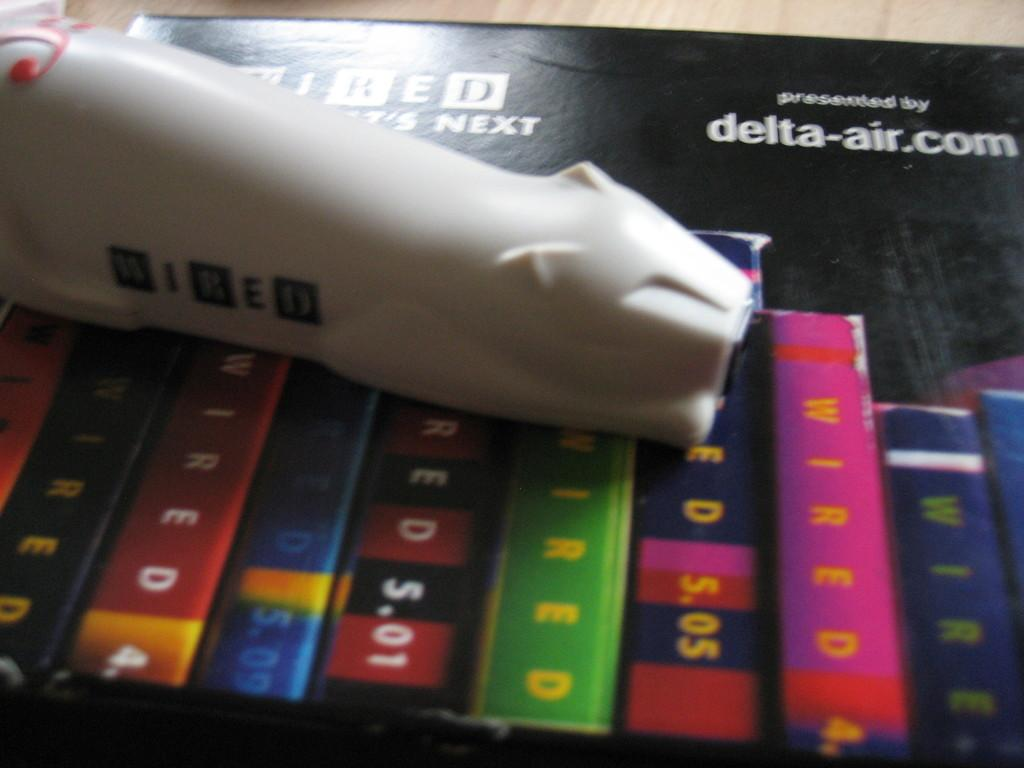Provide a one-sentence caption for the provided image. Looks like a flight schedule, it is presented by delta-air.com. 